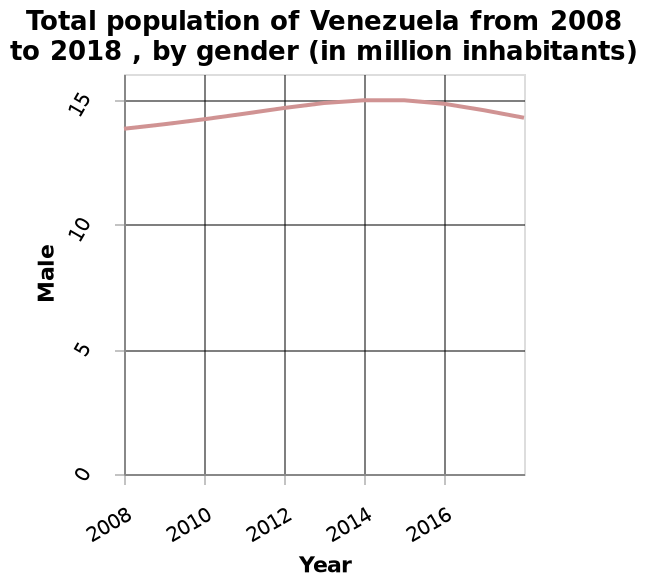<image>
Offer a thorough analysis of the image. The male population of Venezuela increased at an even rate from 2008 till 2014 but then slowly declined back down agan. What has happened to the male population in Venezuela as of 2016?  As of 2016, the male population in Venezuela has slowly started to decrease. please summary the statistics and relations of the chart Between 2012 and 2016 the  number of males peaked. Numbers were seen to be rising and finishing at a similar level between 2008 and 2020. What does the y-axis label represent? The y-axis label represents the population of males in Venezuela. What is the specific time period covered by the line graph? The line graph covers the time period from 2008 to 2018. Has the male population in Venezuela consistently increased or decreased over the 8-year period shown in the line chart? The male population in Venezuela has consistently increased over the 8-year period shown in the line chart, except for the year 2016 when it started to decrease. Does the x-axis label represent the population of males in Venezuela? No.The y-axis label represents the population of males in Venezuela. 